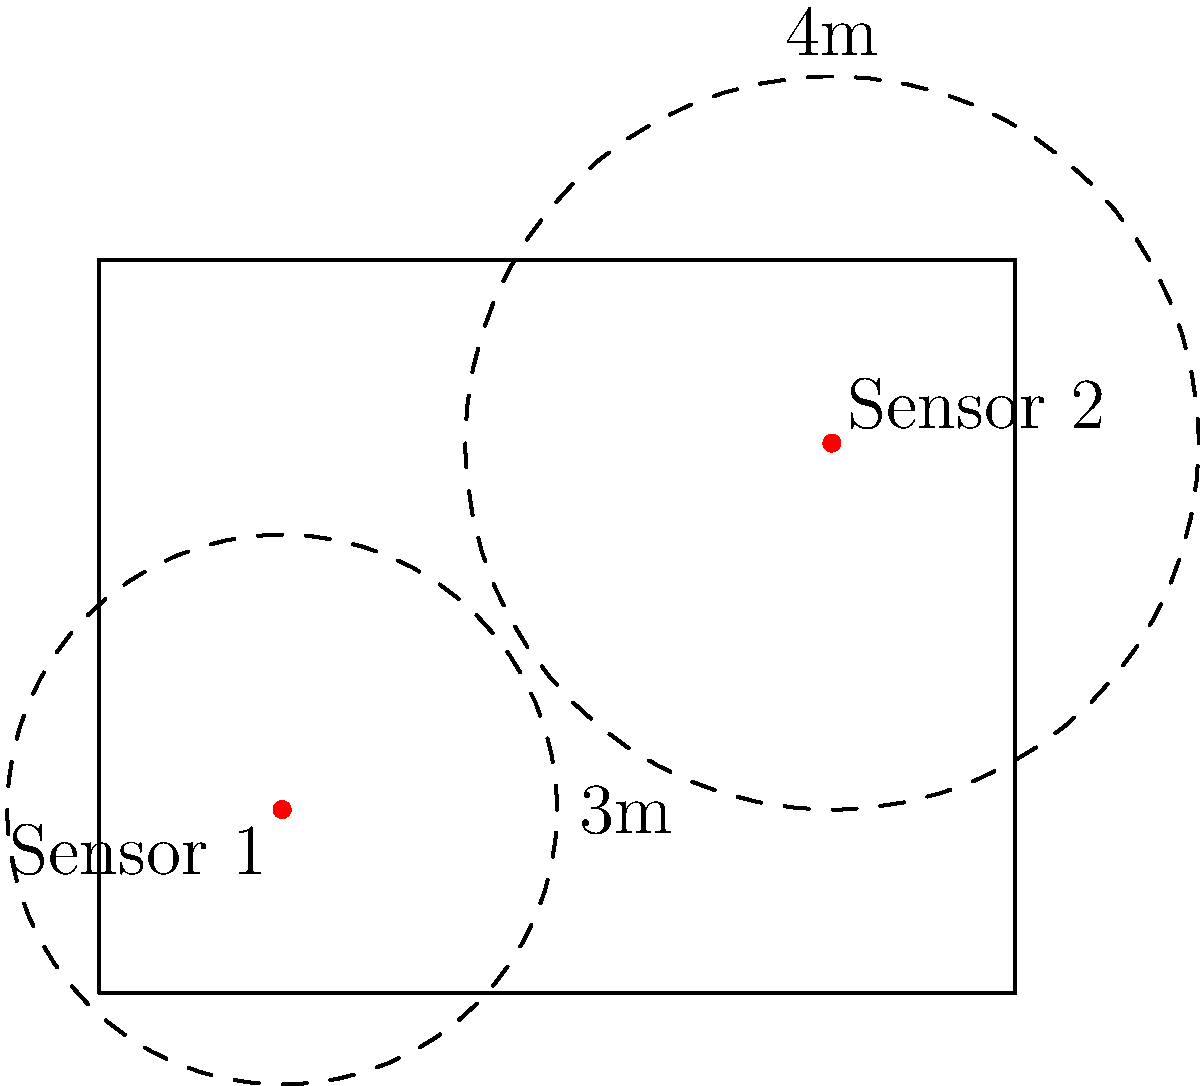In designing an improved security system for a museum, two motion sensors are placed as shown in the floor plan above. Sensor 1 has a detection range of 3 meters, while Sensor 2 has a detection range of 4 meters. What is the total area, in square meters, of the museum floor that is covered by at least one sensor's detection range? (Assume the museum floor is 10m x 8m and π ≈ 3.14) To solve this problem, we'll follow these steps:

1. Calculate the area of each sensor's detection range:
   - Sensor 1: $A_1 = \pi r_1^2 = \pi (3^2) = 28.26$ m²
   - Sensor 2: $A_2 = \pi r_2^2 = \pi (4^2) = 50.24$ m²

2. Calculate the total area of both sensors' ranges:
   $A_{total} = A_1 + A_2 = 28.26 + 50.24 = 78.5$ m²

3. Determine the overlapping area:
   - Distance between sensors: $d = \sqrt{(8-2)^2 + (6-2)^2} = \sqrt{36 + 16} = \sqrt{52} ≈ 7.21$ m
   - Using the formula for the area of intersection of two circles:
     $A_{overlap} = r_1^2 \arccos(\frac{d^2 + r_1^2 - r_2^2}{2dr_1}) + r_2^2 \arccos(\frac{d^2 + r_2^2 - r_1^2}{2dr_2}) - \frac{1}{2}\sqrt{(-d+r_1+r_2)(d+r_1-r_2)(d-r_1+r_2)(d+r_1+r_2)}$
   - Calculating this gives us approximately 2.59 m²

4. Calculate the actual area covered:
   $A_{covered} = A_{total} - A_{overlap} = 78.5 - 2.59 = 75.91$ m²

5. Check if any part of the detection ranges extends beyond the museum floor:
   - The sensors are placed well within the floor plan, so no adjustment is needed.

Therefore, the total area covered by at least one sensor's detection range is approximately 75.91 square meters.
Answer: 75.91 m² 